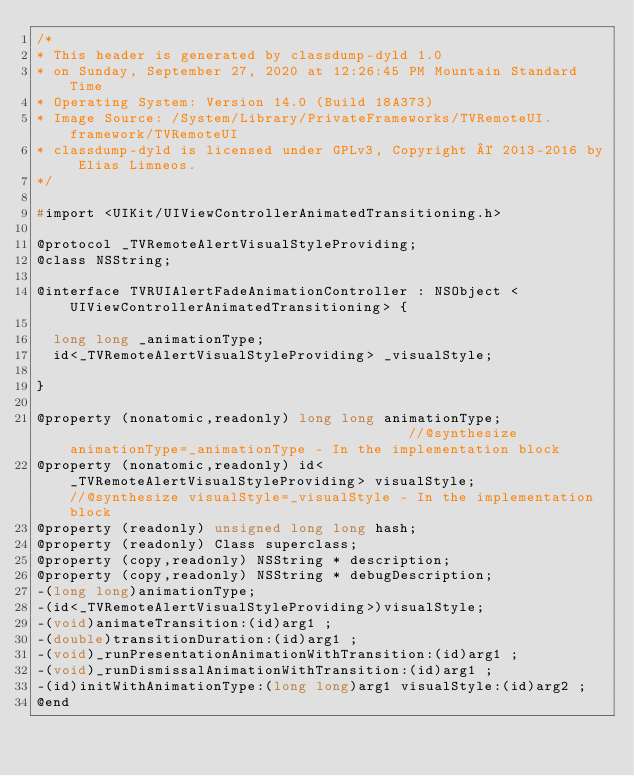Convert code to text. <code><loc_0><loc_0><loc_500><loc_500><_C_>/*
* This header is generated by classdump-dyld 1.0
* on Sunday, September 27, 2020 at 12:26:45 PM Mountain Standard Time
* Operating System: Version 14.0 (Build 18A373)
* Image Source: /System/Library/PrivateFrameworks/TVRemoteUI.framework/TVRemoteUI
* classdump-dyld is licensed under GPLv3, Copyright © 2013-2016 by Elias Limneos.
*/

#import <UIKit/UIViewControllerAnimatedTransitioning.h>

@protocol _TVRemoteAlertVisualStyleProviding;
@class NSString;

@interface TVRUIAlertFadeAnimationController : NSObject <UIViewControllerAnimatedTransitioning> {

	long long _animationType;
	id<_TVRemoteAlertVisualStyleProviding> _visualStyle;

}

@property (nonatomic,readonly) long long animationType;                                         //@synthesize animationType=_animationType - In the implementation block
@property (nonatomic,readonly) id<_TVRemoteAlertVisualStyleProviding> visualStyle;              //@synthesize visualStyle=_visualStyle - In the implementation block
@property (readonly) unsigned long long hash; 
@property (readonly) Class superclass; 
@property (copy,readonly) NSString * description; 
@property (copy,readonly) NSString * debugDescription; 
-(long long)animationType;
-(id<_TVRemoteAlertVisualStyleProviding>)visualStyle;
-(void)animateTransition:(id)arg1 ;
-(double)transitionDuration:(id)arg1 ;
-(void)_runPresentationAnimationWithTransition:(id)arg1 ;
-(void)_runDismissalAnimationWithTransition:(id)arg1 ;
-(id)initWithAnimationType:(long long)arg1 visualStyle:(id)arg2 ;
@end

</code> 